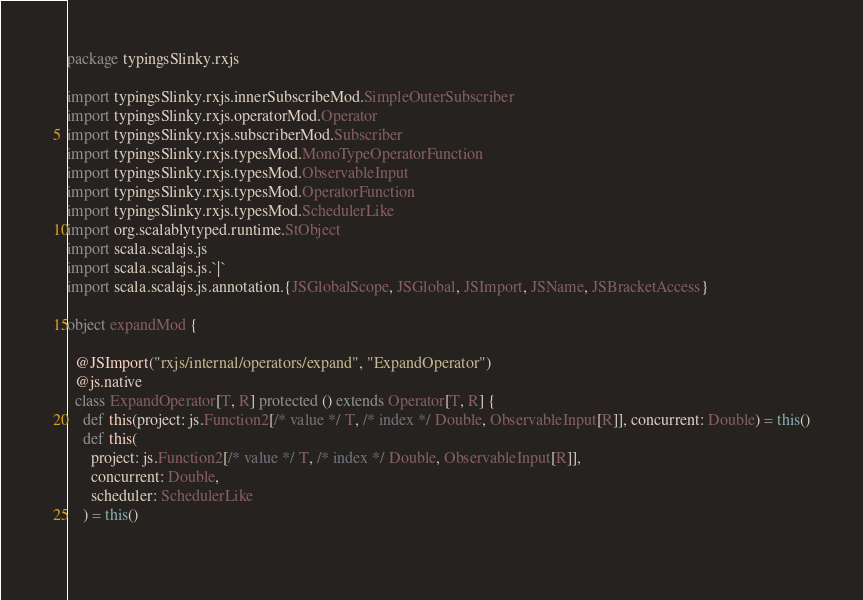<code> <loc_0><loc_0><loc_500><loc_500><_Scala_>package typingsSlinky.rxjs

import typingsSlinky.rxjs.innerSubscribeMod.SimpleOuterSubscriber
import typingsSlinky.rxjs.operatorMod.Operator
import typingsSlinky.rxjs.subscriberMod.Subscriber
import typingsSlinky.rxjs.typesMod.MonoTypeOperatorFunction
import typingsSlinky.rxjs.typesMod.ObservableInput
import typingsSlinky.rxjs.typesMod.OperatorFunction
import typingsSlinky.rxjs.typesMod.SchedulerLike
import org.scalablytyped.runtime.StObject
import scala.scalajs.js
import scala.scalajs.js.`|`
import scala.scalajs.js.annotation.{JSGlobalScope, JSGlobal, JSImport, JSName, JSBracketAccess}

object expandMod {
  
  @JSImport("rxjs/internal/operators/expand", "ExpandOperator")
  @js.native
  class ExpandOperator[T, R] protected () extends Operator[T, R] {
    def this(project: js.Function2[/* value */ T, /* index */ Double, ObservableInput[R]], concurrent: Double) = this()
    def this(
      project: js.Function2[/* value */ T, /* index */ Double, ObservableInput[R]],
      concurrent: Double,
      scheduler: SchedulerLike
    ) = this()
    </code> 